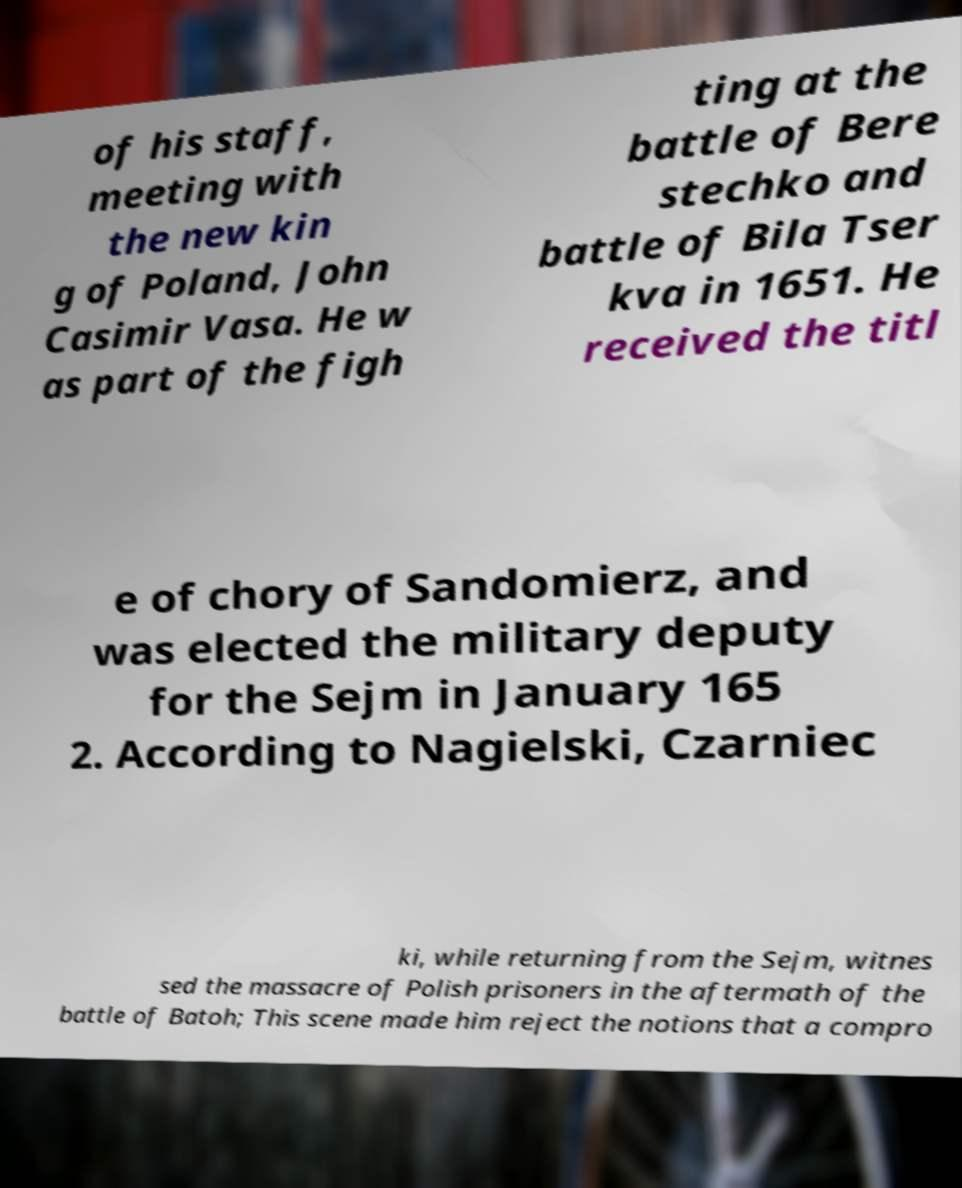Can you read and provide the text displayed in the image?This photo seems to have some interesting text. Can you extract and type it out for me? of his staff, meeting with the new kin g of Poland, John Casimir Vasa. He w as part of the figh ting at the battle of Bere stechko and battle of Bila Tser kva in 1651. He received the titl e of chory of Sandomierz, and was elected the military deputy for the Sejm in January 165 2. According to Nagielski, Czarniec ki, while returning from the Sejm, witnes sed the massacre of Polish prisoners in the aftermath of the battle of Batoh; This scene made him reject the notions that a compro 